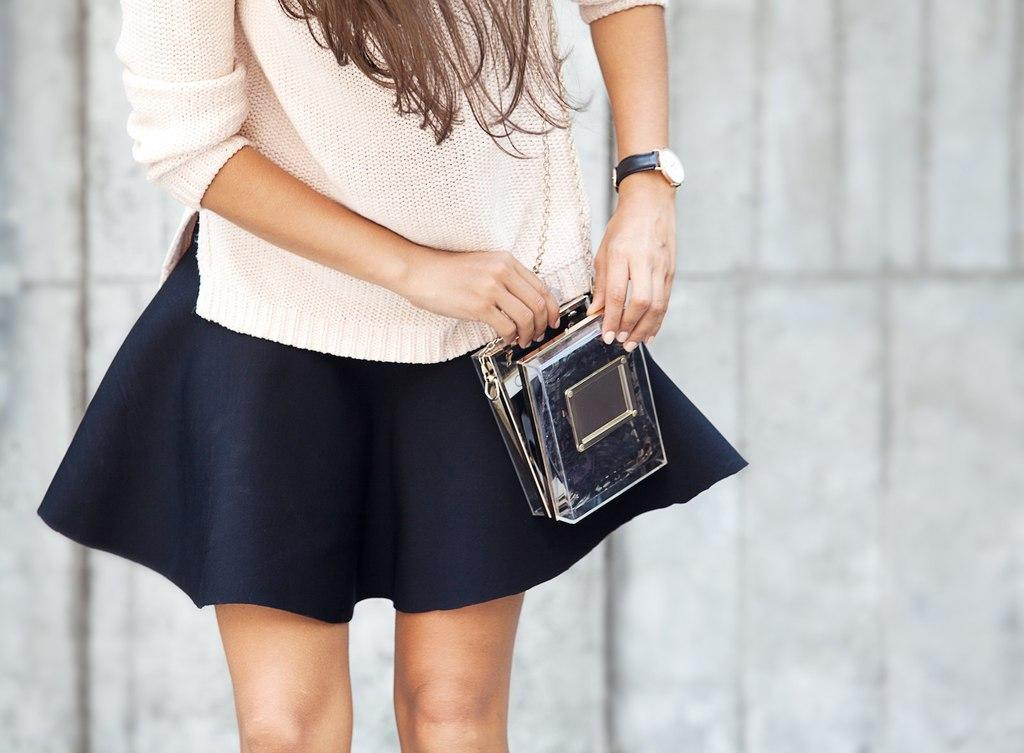Who is present in the image? There is a woman in the image. What is the woman holding or carrying? The woman is carrying a bag. What can be seen in the background of the image? There is a wall in the background of the image. What type of riddle can be seen written on the wall in the image? There is no riddle visible on the wall in the image. 